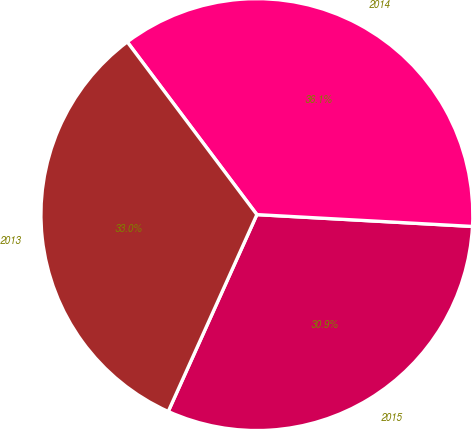<chart> <loc_0><loc_0><loc_500><loc_500><pie_chart><fcel>2015<fcel>2014<fcel>2013<nl><fcel>30.86%<fcel>36.12%<fcel>33.02%<nl></chart> 